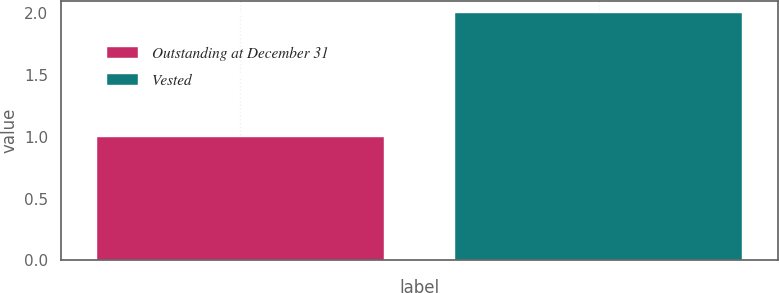Convert chart to OTSL. <chart><loc_0><loc_0><loc_500><loc_500><bar_chart><fcel>Outstanding at December 31<fcel>Vested<nl><fcel>1<fcel>2<nl></chart> 